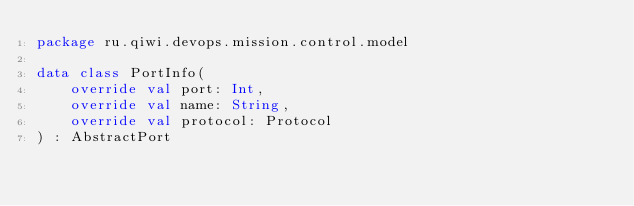Convert code to text. <code><loc_0><loc_0><loc_500><loc_500><_Kotlin_>package ru.qiwi.devops.mission.control.model

data class PortInfo(
    override val port: Int,
    override val name: String,
    override val protocol: Protocol
) : AbstractPort</code> 